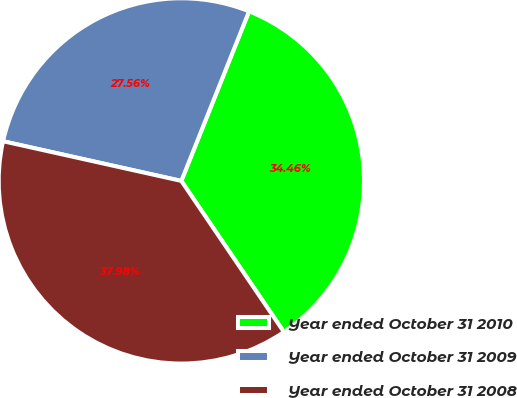<chart> <loc_0><loc_0><loc_500><loc_500><pie_chart><fcel>Year ended October 31 2010<fcel>Year ended October 31 2009<fcel>Year ended October 31 2008<nl><fcel>34.46%<fcel>27.56%<fcel>37.98%<nl></chart> 